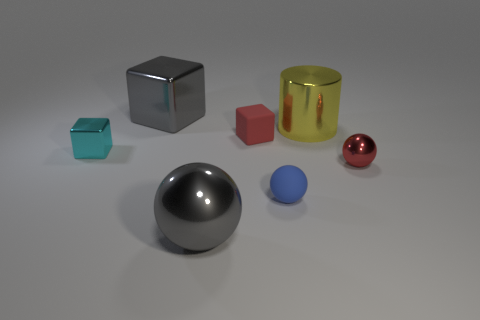Is the shape of the cyan metal thing the same as the tiny blue object?
Your response must be concise. No. There is a red thing that is behind the small red sphere; what size is it?
Offer a very short reply. Small. Are there any small rubber objects that have the same color as the small metal sphere?
Provide a succinct answer. Yes. Do the gray object in front of the gray shiny block and the metal cylinder have the same size?
Your answer should be compact. Yes. What is the color of the tiny metallic block?
Offer a very short reply. Cyan. There is a object that is to the left of the large object that is on the left side of the gray sphere; what color is it?
Offer a terse response. Cyan. Are there any tiny red spheres made of the same material as the small red cube?
Your answer should be very brief. No. The cylinder behind the rubber object that is in front of the tiny red block is made of what material?
Provide a succinct answer. Metal. What number of gray objects are the same shape as the tiny cyan thing?
Provide a succinct answer. 1. What is the shape of the big yellow shiny thing?
Make the answer very short. Cylinder. 